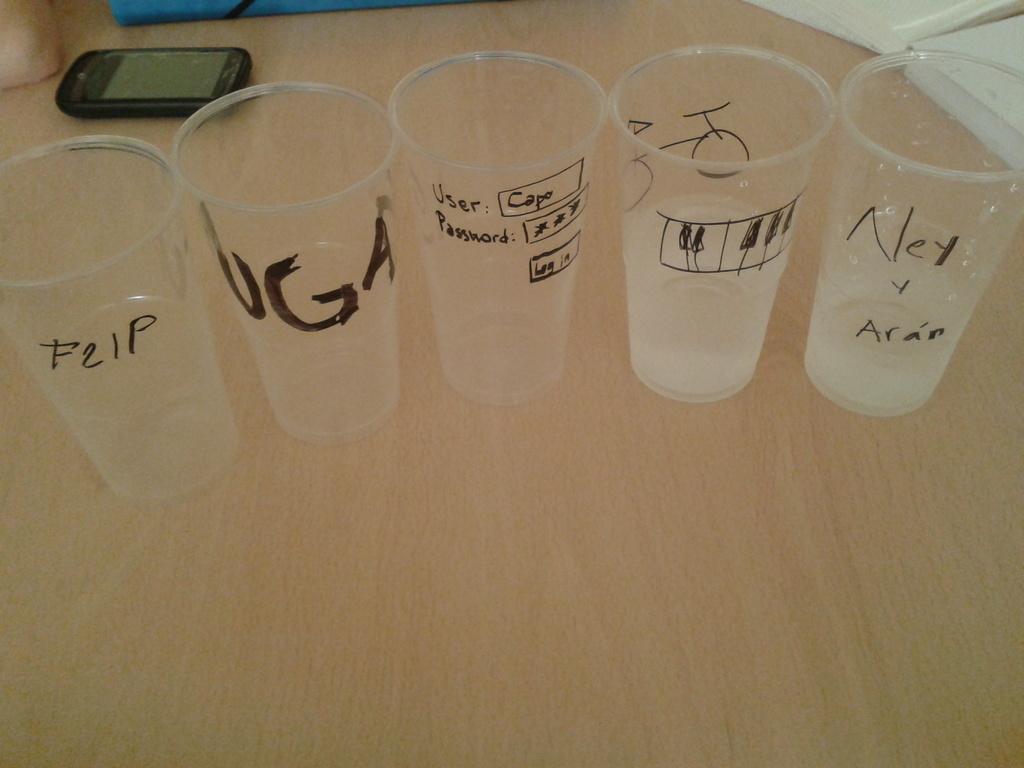What's the username on the cup in the middle?
Provide a succinct answer. Capo. What name is written on the cup on the very right?
Make the answer very short. Ney y aran. 